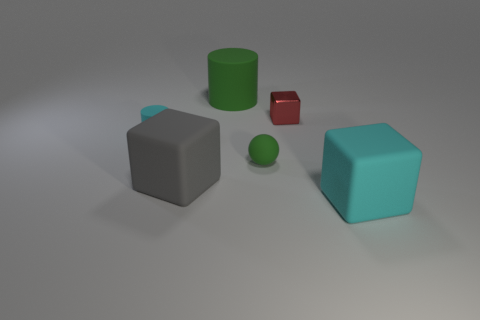What number of other objects are the same material as the big gray cube?
Your answer should be compact. 4. How many big cyan objects have the same shape as the small red shiny thing?
Offer a very short reply. 1. There is a big thing that is right of the gray matte thing and in front of the tiny red block; what is its color?
Your answer should be compact. Cyan. What number of green cylinders are there?
Offer a terse response. 1. Is the cyan matte cylinder the same size as the gray rubber cube?
Make the answer very short. No. Is there a small rubber object of the same color as the matte ball?
Your response must be concise. No. There is a cyan rubber thing in front of the tiny cyan rubber cylinder; is its shape the same as the gray thing?
Your response must be concise. Yes. What number of rubber things are the same size as the metal cube?
Make the answer very short. 2. How many big matte cylinders are to the left of the green object left of the green rubber ball?
Your response must be concise. 0. Is the block on the right side of the tiny block made of the same material as the small ball?
Your answer should be very brief. Yes. 